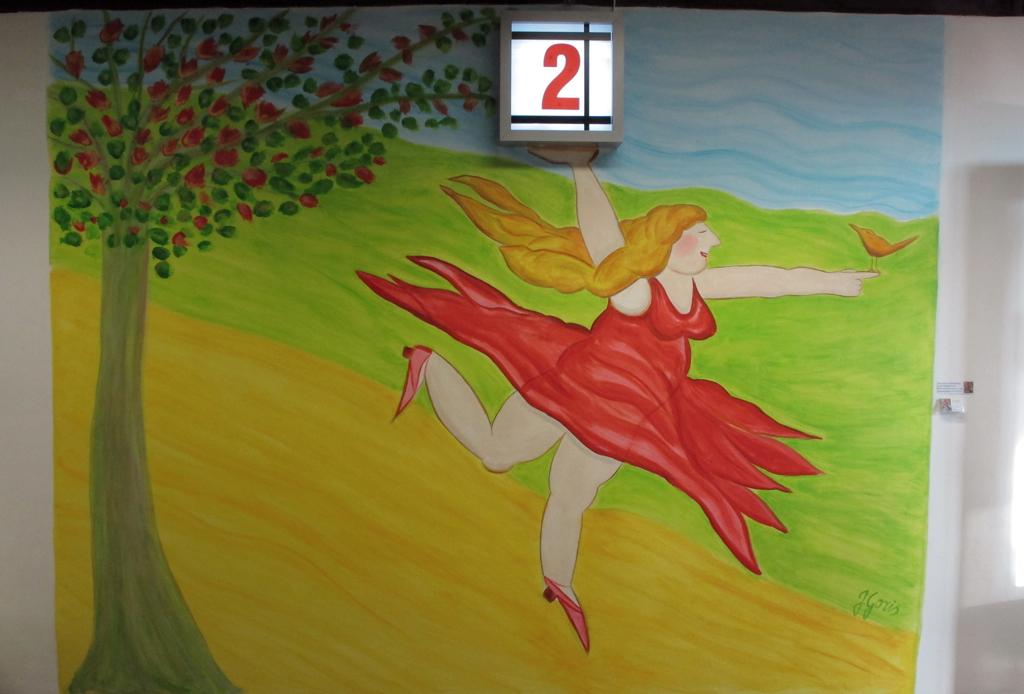What is the main object in the image? There is a board in the image. What type of artwork can be seen on the board? There is a painting of a lady, a painting of a bird, and a painting of a tree on the board. Is there any text present in the image? Yes, there is text on the wall in the image. What color is the sweater worn by the lady in the painting? There is no sweater visible in the painting of the lady, as the painting only depicts the lady's face and upper body. 